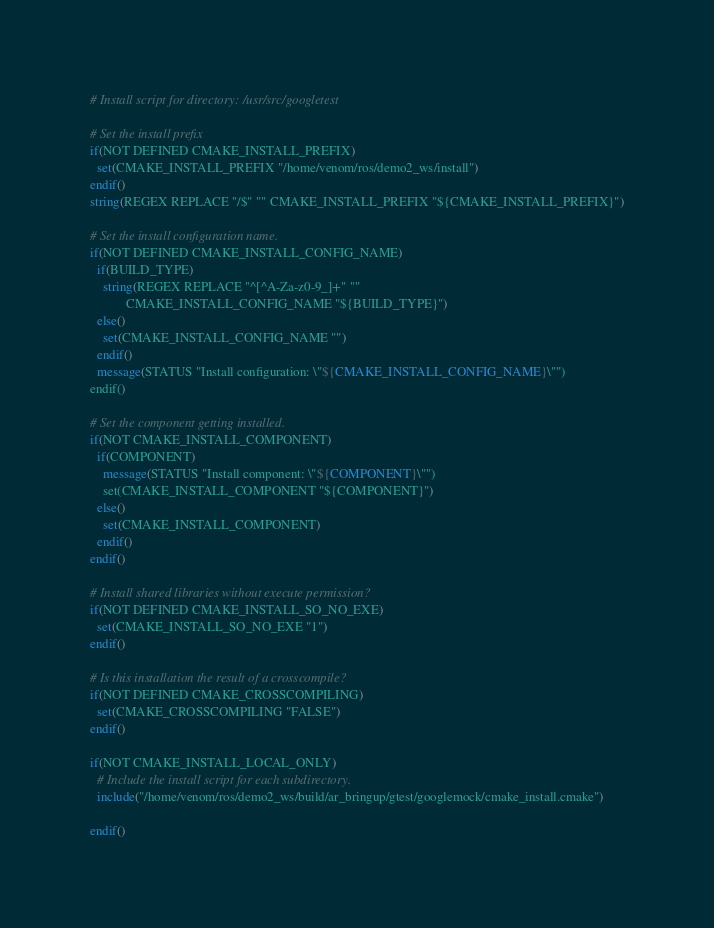<code> <loc_0><loc_0><loc_500><loc_500><_CMake_># Install script for directory: /usr/src/googletest

# Set the install prefix
if(NOT DEFINED CMAKE_INSTALL_PREFIX)
  set(CMAKE_INSTALL_PREFIX "/home/venom/ros/demo2_ws/install")
endif()
string(REGEX REPLACE "/$" "" CMAKE_INSTALL_PREFIX "${CMAKE_INSTALL_PREFIX}")

# Set the install configuration name.
if(NOT DEFINED CMAKE_INSTALL_CONFIG_NAME)
  if(BUILD_TYPE)
    string(REGEX REPLACE "^[^A-Za-z0-9_]+" ""
           CMAKE_INSTALL_CONFIG_NAME "${BUILD_TYPE}")
  else()
    set(CMAKE_INSTALL_CONFIG_NAME "")
  endif()
  message(STATUS "Install configuration: \"${CMAKE_INSTALL_CONFIG_NAME}\"")
endif()

# Set the component getting installed.
if(NOT CMAKE_INSTALL_COMPONENT)
  if(COMPONENT)
    message(STATUS "Install component: \"${COMPONENT}\"")
    set(CMAKE_INSTALL_COMPONENT "${COMPONENT}")
  else()
    set(CMAKE_INSTALL_COMPONENT)
  endif()
endif()

# Install shared libraries without execute permission?
if(NOT DEFINED CMAKE_INSTALL_SO_NO_EXE)
  set(CMAKE_INSTALL_SO_NO_EXE "1")
endif()

# Is this installation the result of a crosscompile?
if(NOT DEFINED CMAKE_CROSSCOMPILING)
  set(CMAKE_CROSSCOMPILING "FALSE")
endif()

if(NOT CMAKE_INSTALL_LOCAL_ONLY)
  # Include the install script for each subdirectory.
  include("/home/venom/ros/demo2_ws/build/ar_bringup/gtest/googlemock/cmake_install.cmake")

endif()

</code> 